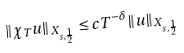<formula> <loc_0><loc_0><loc_500><loc_500>\| \chi _ { T } u \| _ { X _ { s , \frac { 1 } { 2 } } } \leq c T ^ { - \delta } \| u \| _ { X _ { s , \frac { 1 } { 2 } } }</formula> 